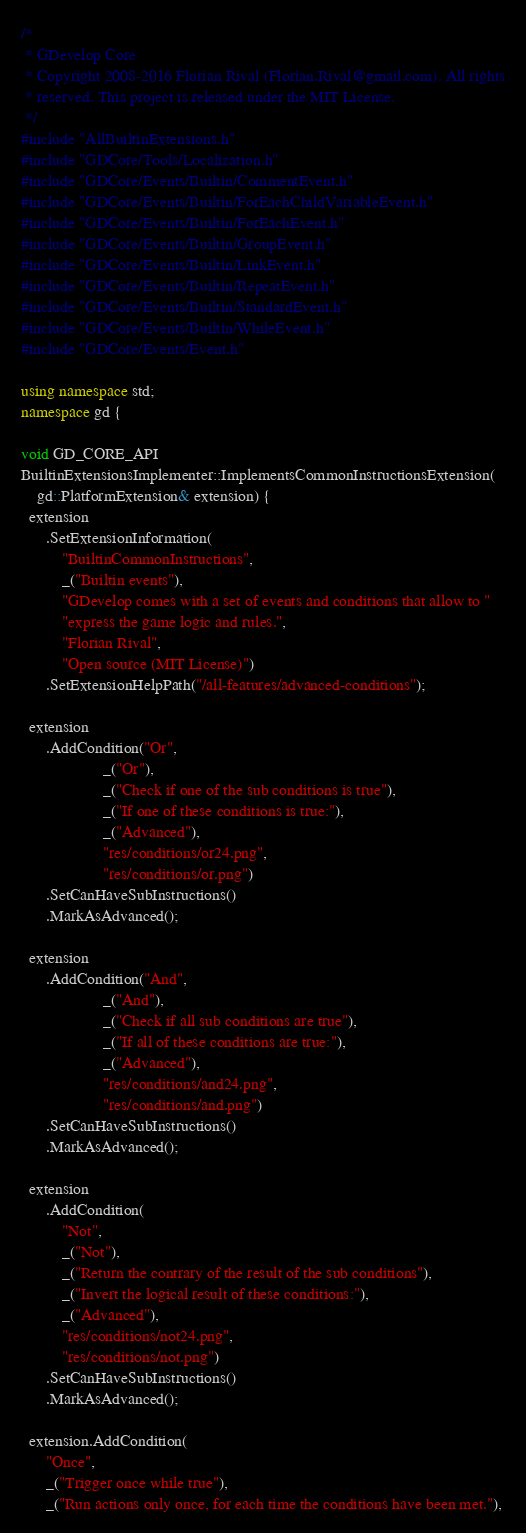<code> <loc_0><loc_0><loc_500><loc_500><_C++_>/*
 * GDevelop Core
 * Copyright 2008-2016 Florian Rival (Florian.Rival@gmail.com). All rights
 * reserved. This project is released under the MIT License.
 */
#include "AllBuiltinExtensions.h"
#include "GDCore/Tools/Localization.h"
#include "GDCore/Events/Builtin/CommentEvent.h"
#include "GDCore/Events/Builtin/ForEachChildVariableEvent.h"
#include "GDCore/Events/Builtin/ForEachEvent.h"
#include "GDCore/Events/Builtin/GroupEvent.h"
#include "GDCore/Events/Builtin/LinkEvent.h"
#include "GDCore/Events/Builtin/RepeatEvent.h"
#include "GDCore/Events/Builtin/StandardEvent.h"
#include "GDCore/Events/Builtin/WhileEvent.h"
#include "GDCore/Events/Event.h"

using namespace std;
namespace gd {

void GD_CORE_API
BuiltinExtensionsImplementer::ImplementsCommonInstructionsExtension(
    gd::PlatformExtension& extension) {
  extension
      .SetExtensionInformation(
          "BuiltinCommonInstructions",
          _("Builtin events"),
          "GDevelop comes with a set of events and conditions that allow to "
          "express the game logic and rules.",
          "Florian Rival",
          "Open source (MIT License)")
      .SetExtensionHelpPath("/all-features/advanced-conditions");

  extension
      .AddCondition("Or",
                    _("Or"),
                    _("Check if one of the sub conditions is true"),
                    _("If one of these conditions is true:"),
                    _("Advanced"),
                    "res/conditions/or24.png",
                    "res/conditions/or.png")
      .SetCanHaveSubInstructions()
      .MarkAsAdvanced();

  extension
      .AddCondition("And",
                    _("And"),
                    _("Check if all sub conditions are true"),
                    _("If all of these conditions are true:"),
                    _("Advanced"),
                    "res/conditions/and24.png",
                    "res/conditions/and.png")
      .SetCanHaveSubInstructions()
      .MarkAsAdvanced();

  extension
      .AddCondition(
          "Not",
          _("Not"),
          _("Return the contrary of the result of the sub conditions"),
          _("Invert the logical result of these conditions:"),
          _("Advanced"),
          "res/conditions/not24.png",
          "res/conditions/not.png")
      .SetCanHaveSubInstructions()
      .MarkAsAdvanced();

  extension.AddCondition(
      "Once",
      _("Trigger once while true"),
      _("Run actions only once, for each time the conditions have been met."),</code> 